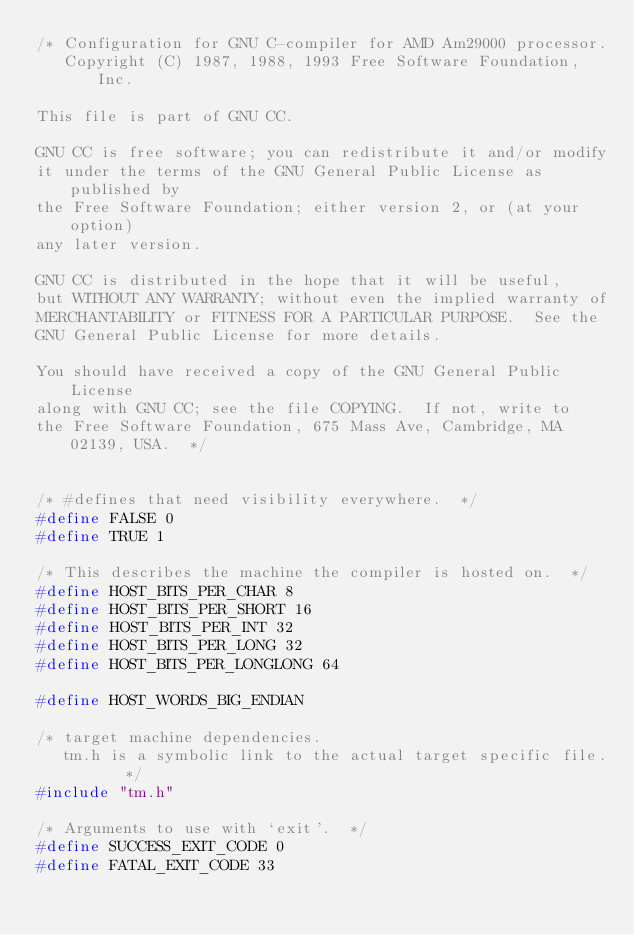<code> <loc_0><loc_0><loc_500><loc_500><_C_>/* Configuration for GNU C-compiler for AMD Am29000 processor. 
   Copyright (C) 1987, 1988, 1993 Free Software Foundation, Inc.

This file is part of GNU CC.

GNU CC is free software; you can redistribute it and/or modify
it under the terms of the GNU General Public License as published by
the Free Software Foundation; either version 2, or (at your option)
any later version.

GNU CC is distributed in the hope that it will be useful,
but WITHOUT ANY WARRANTY; without even the implied warranty of
MERCHANTABILITY or FITNESS FOR A PARTICULAR PURPOSE.  See the
GNU General Public License for more details.

You should have received a copy of the GNU General Public License
along with GNU CC; see the file COPYING.  If not, write to
the Free Software Foundation, 675 Mass Ave, Cambridge, MA 02139, USA.  */


/* #defines that need visibility everywhere.  */
#define FALSE 0
#define TRUE 1

/* This describes the machine the compiler is hosted on.  */
#define HOST_BITS_PER_CHAR 8
#define HOST_BITS_PER_SHORT 16
#define HOST_BITS_PER_INT 32
#define HOST_BITS_PER_LONG 32
#define HOST_BITS_PER_LONGLONG 64

#define HOST_WORDS_BIG_ENDIAN

/* target machine dependencies.
   tm.h is a symbolic link to the actual target specific file.   */
#include "tm.h"

/* Arguments to use with `exit'.  */
#define SUCCESS_EXIT_CODE 0
#define FATAL_EXIT_CODE 33
</code> 